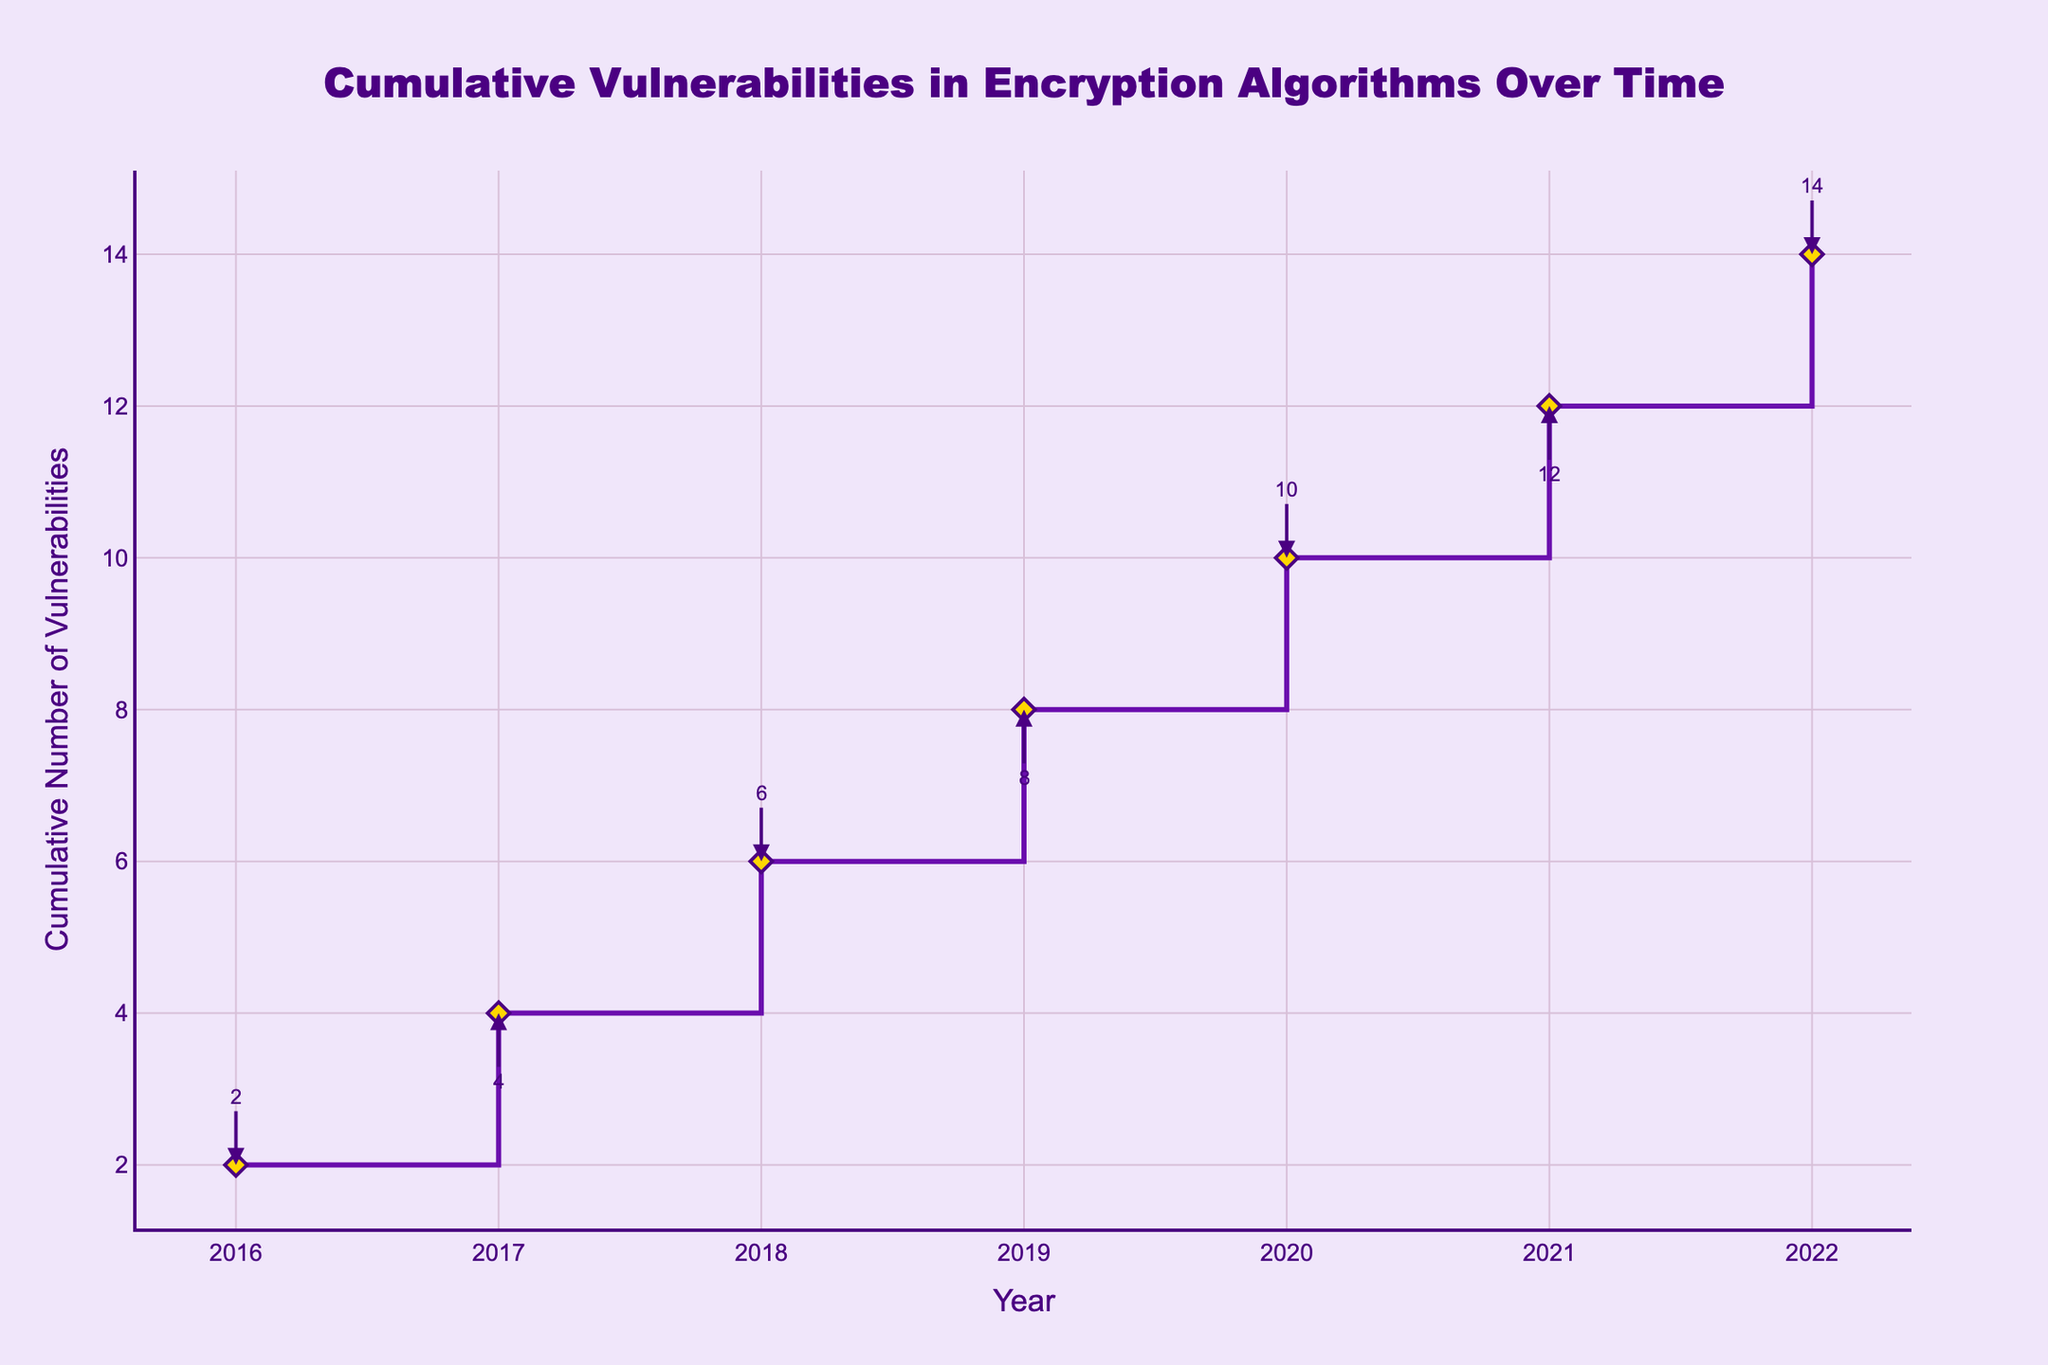How many cumulative vulnerabilities are there by the end of 2022? The y-axis of the plot shows the cumulative number of vulnerabilities. At the point corresponding to the year 2022, the number indicated is the total count by that year.
Answer: 14 What is the title of the plot? The title is shown at the top center of the plot.
Answer: Cumulative Vulnerabilities in Encryption Algorithms Over Time Which year has the highest cumulative number of vulnerabilities in the plot? By examining the highest point on the stair plot, we can ascertain the year corresponding to the maximum value on the y-axis.
Answer: 2022 How many new vulnerabilities were discovered between 2018 and 2020? Find the difference in the cumulative number of vulnerabilities between 2020 and 2018 by examining the corresponding y-values on the plot.
Answer: 4 Compare the number of vulnerabilities discovered in 2017 to those in 2021. Which year had more vulnerabilities? Look at the cumulative number of vulnerabilities at the years 2017 and 2021 and compare their values on the y-axis.
Answer: 2021 How many vulnerabilities were discovered in 2016? Check the y-axis value for the year 2016, since it represents the cumulative vulnerabilities up to that year.
Answer: 2 What is the trend in the number of vulnerabilities from 2016 to 2020? Observe the stair plot's trajectory from 2016 to 2020 on the x-axis to identify if the number of vulnerabilities increased, decreased, or remained constant.
Answer: Increase In which year did the cumulative number of vulnerabilities first reach 10? Identify the year on the x-axis where the y-axis first indicates a value of 10.
Answer: 2020 How does the rate of vulnerability discovery between 2019 and 2021 compare to that between 2016 and 2018? Calculate the difference in cumulative vulnerabilities between the years 2019-2021 and compare it to the difference between 2016-2018 by observing the plot's data points and their corresponding values.
Answer: Faster between 2019 and 2021 